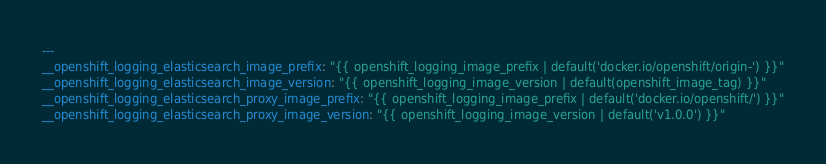<code> <loc_0><loc_0><loc_500><loc_500><_YAML_>---
__openshift_logging_elasticsearch_image_prefix: "{{ openshift_logging_image_prefix | default('docker.io/openshift/origin-') }}"
__openshift_logging_elasticsearch_image_version: "{{ openshift_logging_image_version | default(openshift_image_tag) }}"
__openshift_logging_elasticsearch_proxy_image_prefix: "{{ openshift_logging_image_prefix | default('docker.io/openshift/') }}"
__openshift_logging_elasticsearch_proxy_image_version: "{{ openshift_logging_image_version | default('v1.0.0') }}"
</code> 